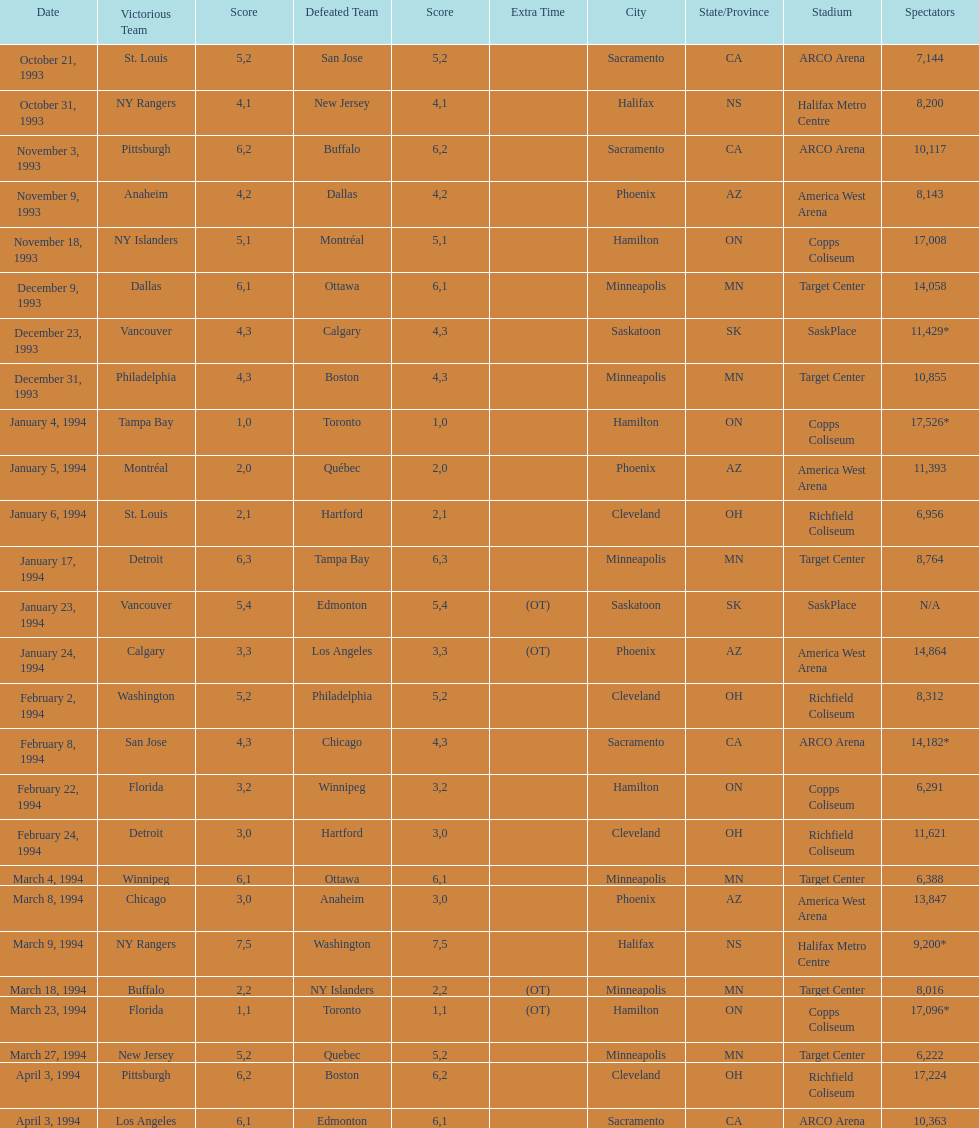How many neutral site games resulted in overtime (ot)? 4. 